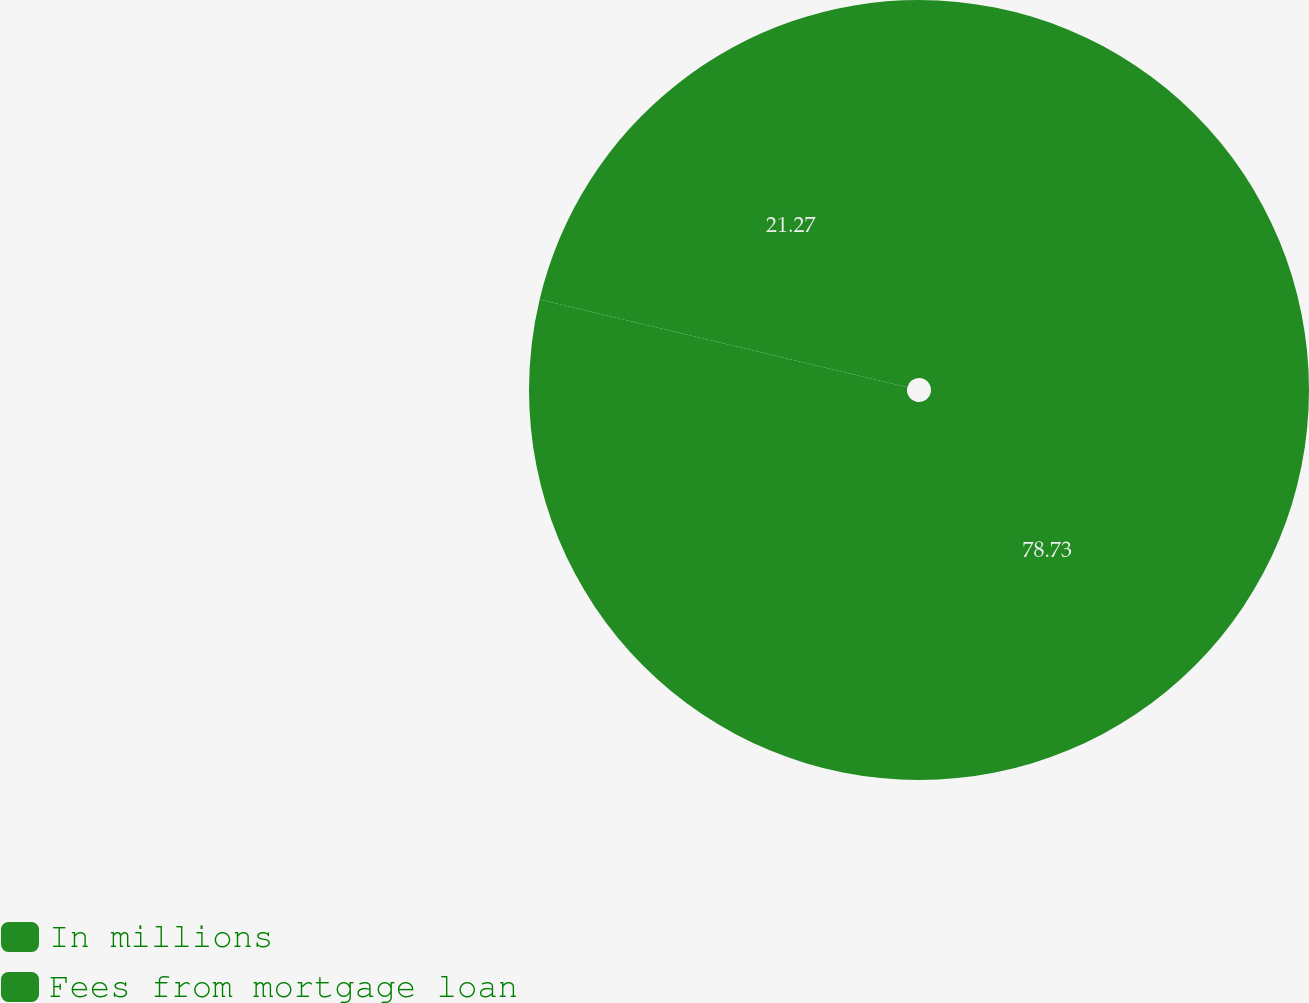Convert chart to OTSL. <chart><loc_0><loc_0><loc_500><loc_500><pie_chart><fcel>In millions<fcel>Fees from mortgage loan<nl><fcel>78.73%<fcel>21.27%<nl></chart> 